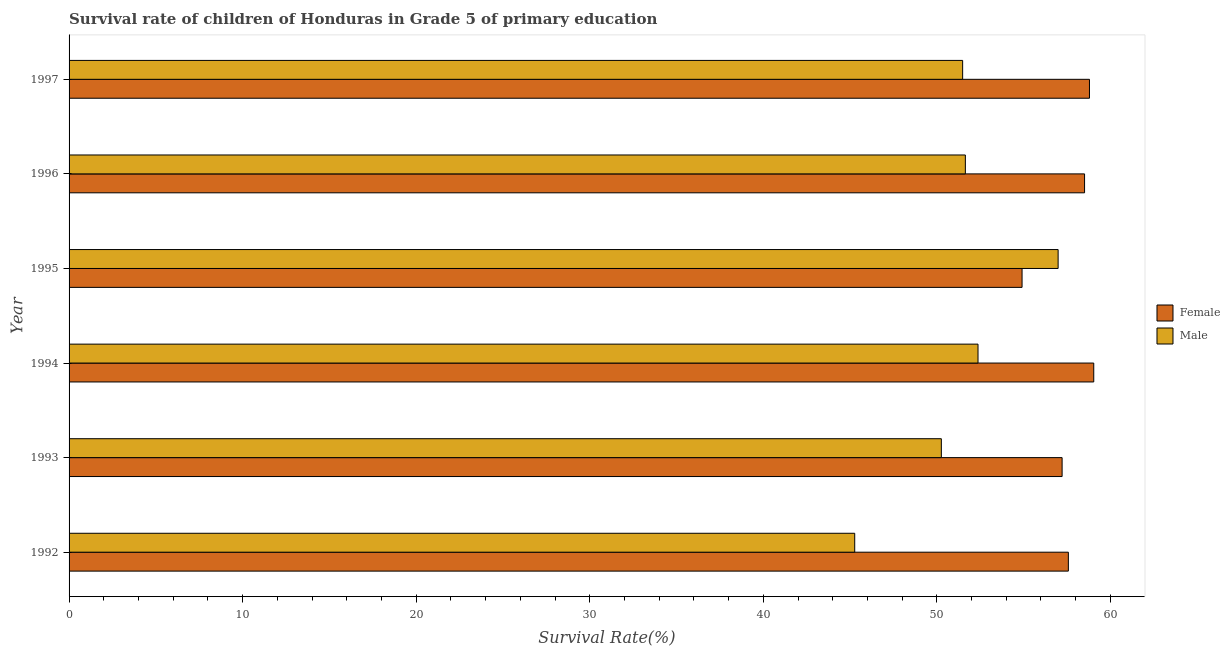How many different coloured bars are there?
Provide a short and direct response. 2. How many groups of bars are there?
Provide a succinct answer. 6. Are the number of bars on each tick of the Y-axis equal?
Offer a terse response. Yes. What is the label of the 4th group of bars from the top?
Keep it short and to the point. 1994. In how many cases, is the number of bars for a given year not equal to the number of legend labels?
Ensure brevity in your answer.  0. What is the survival rate of female students in primary education in 1996?
Ensure brevity in your answer.  58.51. Across all years, what is the maximum survival rate of male students in primary education?
Provide a short and direct response. 56.99. Across all years, what is the minimum survival rate of female students in primary education?
Your answer should be compact. 54.91. In which year was the survival rate of male students in primary education maximum?
Ensure brevity in your answer.  1995. In which year was the survival rate of male students in primary education minimum?
Provide a succinct answer. 1992. What is the total survival rate of female students in primary education in the graph?
Your answer should be compact. 346.05. What is the difference between the survival rate of male students in primary education in 1994 and that in 1995?
Provide a succinct answer. -4.62. What is the difference between the survival rate of female students in primary education in 1995 and the survival rate of male students in primary education in 1993?
Keep it short and to the point. 4.65. What is the average survival rate of male students in primary education per year?
Your answer should be very brief. 51.34. In the year 1993, what is the difference between the survival rate of female students in primary education and survival rate of male students in primary education?
Offer a terse response. 6.96. Is the survival rate of female students in primary education in 1993 less than that in 1995?
Keep it short and to the point. No. Is the difference between the survival rate of male students in primary education in 1993 and 1994 greater than the difference between the survival rate of female students in primary education in 1993 and 1994?
Offer a very short reply. No. What is the difference between the highest and the second highest survival rate of female students in primary education?
Give a very brief answer. 0.25. What is the difference between the highest and the lowest survival rate of male students in primary education?
Your answer should be compact. 11.72. In how many years, is the survival rate of male students in primary education greater than the average survival rate of male students in primary education taken over all years?
Your answer should be very brief. 4. Are all the bars in the graph horizontal?
Provide a short and direct response. Yes. How many years are there in the graph?
Keep it short and to the point. 6. Where does the legend appear in the graph?
Ensure brevity in your answer.  Center right. What is the title of the graph?
Your answer should be compact. Survival rate of children of Honduras in Grade 5 of primary education. What is the label or title of the X-axis?
Provide a succinct answer. Survival Rate(%). What is the Survival Rate(%) of Female in 1992?
Give a very brief answer. 57.58. What is the Survival Rate(%) in Male in 1992?
Provide a short and direct response. 45.27. What is the Survival Rate(%) in Female in 1993?
Keep it short and to the point. 57.22. What is the Survival Rate(%) in Male in 1993?
Give a very brief answer. 50.26. What is the Survival Rate(%) of Female in 1994?
Offer a terse response. 59.04. What is the Survival Rate(%) in Male in 1994?
Give a very brief answer. 52.37. What is the Survival Rate(%) of Female in 1995?
Give a very brief answer. 54.91. What is the Survival Rate(%) in Male in 1995?
Provide a short and direct response. 56.99. What is the Survival Rate(%) of Female in 1996?
Your response must be concise. 58.51. What is the Survival Rate(%) of Male in 1996?
Provide a succinct answer. 51.64. What is the Survival Rate(%) in Female in 1997?
Offer a very short reply. 58.79. What is the Survival Rate(%) in Male in 1997?
Your answer should be compact. 51.49. Across all years, what is the maximum Survival Rate(%) of Female?
Your answer should be very brief. 59.04. Across all years, what is the maximum Survival Rate(%) of Male?
Offer a terse response. 56.99. Across all years, what is the minimum Survival Rate(%) in Female?
Ensure brevity in your answer.  54.91. Across all years, what is the minimum Survival Rate(%) of Male?
Your response must be concise. 45.27. What is the total Survival Rate(%) of Female in the graph?
Offer a terse response. 346.05. What is the total Survival Rate(%) in Male in the graph?
Provide a succinct answer. 308.02. What is the difference between the Survival Rate(%) of Female in 1992 and that in 1993?
Offer a very short reply. 0.36. What is the difference between the Survival Rate(%) in Male in 1992 and that in 1993?
Offer a very short reply. -4.99. What is the difference between the Survival Rate(%) of Female in 1992 and that in 1994?
Provide a succinct answer. -1.46. What is the difference between the Survival Rate(%) in Male in 1992 and that in 1994?
Your answer should be very brief. -7.1. What is the difference between the Survival Rate(%) in Female in 1992 and that in 1995?
Your answer should be compact. 2.67. What is the difference between the Survival Rate(%) of Male in 1992 and that in 1995?
Give a very brief answer. -11.72. What is the difference between the Survival Rate(%) in Female in 1992 and that in 1996?
Your answer should be compact. -0.93. What is the difference between the Survival Rate(%) of Male in 1992 and that in 1996?
Offer a very short reply. -6.37. What is the difference between the Survival Rate(%) in Female in 1992 and that in 1997?
Ensure brevity in your answer.  -1.22. What is the difference between the Survival Rate(%) in Male in 1992 and that in 1997?
Offer a very short reply. -6.22. What is the difference between the Survival Rate(%) of Female in 1993 and that in 1994?
Keep it short and to the point. -1.82. What is the difference between the Survival Rate(%) of Male in 1993 and that in 1994?
Ensure brevity in your answer.  -2.11. What is the difference between the Survival Rate(%) of Female in 1993 and that in 1995?
Provide a succinct answer. 2.31. What is the difference between the Survival Rate(%) in Male in 1993 and that in 1995?
Offer a terse response. -6.73. What is the difference between the Survival Rate(%) of Female in 1993 and that in 1996?
Ensure brevity in your answer.  -1.29. What is the difference between the Survival Rate(%) in Male in 1993 and that in 1996?
Your answer should be compact. -1.38. What is the difference between the Survival Rate(%) in Female in 1993 and that in 1997?
Provide a short and direct response. -1.58. What is the difference between the Survival Rate(%) of Male in 1993 and that in 1997?
Provide a succinct answer. -1.23. What is the difference between the Survival Rate(%) of Female in 1994 and that in 1995?
Provide a short and direct response. 4.13. What is the difference between the Survival Rate(%) of Male in 1994 and that in 1995?
Make the answer very short. -4.62. What is the difference between the Survival Rate(%) of Female in 1994 and that in 1996?
Provide a short and direct response. 0.53. What is the difference between the Survival Rate(%) of Male in 1994 and that in 1996?
Ensure brevity in your answer.  0.73. What is the difference between the Survival Rate(%) in Female in 1994 and that in 1997?
Your answer should be compact. 0.25. What is the difference between the Survival Rate(%) of Male in 1994 and that in 1997?
Ensure brevity in your answer.  0.89. What is the difference between the Survival Rate(%) in Female in 1995 and that in 1996?
Provide a short and direct response. -3.6. What is the difference between the Survival Rate(%) in Male in 1995 and that in 1996?
Provide a short and direct response. 5.34. What is the difference between the Survival Rate(%) of Female in 1995 and that in 1997?
Give a very brief answer. -3.88. What is the difference between the Survival Rate(%) in Male in 1995 and that in 1997?
Provide a short and direct response. 5.5. What is the difference between the Survival Rate(%) of Female in 1996 and that in 1997?
Make the answer very short. -0.28. What is the difference between the Survival Rate(%) of Male in 1996 and that in 1997?
Offer a terse response. 0.16. What is the difference between the Survival Rate(%) of Female in 1992 and the Survival Rate(%) of Male in 1993?
Keep it short and to the point. 7.32. What is the difference between the Survival Rate(%) in Female in 1992 and the Survival Rate(%) in Male in 1994?
Ensure brevity in your answer.  5.21. What is the difference between the Survival Rate(%) of Female in 1992 and the Survival Rate(%) of Male in 1995?
Offer a very short reply. 0.59. What is the difference between the Survival Rate(%) in Female in 1992 and the Survival Rate(%) in Male in 1996?
Provide a succinct answer. 5.93. What is the difference between the Survival Rate(%) in Female in 1992 and the Survival Rate(%) in Male in 1997?
Your answer should be very brief. 6.09. What is the difference between the Survival Rate(%) of Female in 1993 and the Survival Rate(%) of Male in 1994?
Keep it short and to the point. 4.84. What is the difference between the Survival Rate(%) in Female in 1993 and the Survival Rate(%) in Male in 1995?
Provide a succinct answer. 0.23. What is the difference between the Survival Rate(%) in Female in 1993 and the Survival Rate(%) in Male in 1996?
Your response must be concise. 5.57. What is the difference between the Survival Rate(%) in Female in 1993 and the Survival Rate(%) in Male in 1997?
Offer a very short reply. 5.73. What is the difference between the Survival Rate(%) of Female in 1994 and the Survival Rate(%) of Male in 1995?
Ensure brevity in your answer.  2.05. What is the difference between the Survival Rate(%) in Female in 1994 and the Survival Rate(%) in Male in 1996?
Your answer should be compact. 7.4. What is the difference between the Survival Rate(%) of Female in 1994 and the Survival Rate(%) of Male in 1997?
Ensure brevity in your answer.  7.55. What is the difference between the Survival Rate(%) of Female in 1995 and the Survival Rate(%) of Male in 1996?
Your response must be concise. 3.27. What is the difference between the Survival Rate(%) of Female in 1995 and the Survival Rate(%) of Male in 1997?
Your response must be concise. 3.42. What is the difference between the Survival Rate(%) of Female in 1996 and the Survival Rate(%) of Male in 1997?
Your response must be concise. 7.02. What is the average Survival Rate(%) in Female per year?
Your answer should be very brief. 57.68. What is the average Survival Rate(%) in Male per year?
Make the answer very short. 51.34. In the year 1992, what is the difference between the Survival Rate(%) in Female and Survival Rate(%) in Male?
Give a very brief answer. 12.31. In the year 1993, what is the difference between the Survival Rate(%) of Female and Survival Rate(%) of Male?
Provide a short and direct response. 6.96. In the year 1994, what is the difference between the Survival Rate(%) of Female and Survival Rate(%) of Male?
Make the answer very short. 6.67. In the year 1995, what is the difference between the Survival Rate(%) in Female and Survival Rate(%) in Male?
Your answer should be compact. -2.08. In the year 1996, what is the difference between the Survival Rate(%) of Female and Survival Rate(%) of Male?
Keep it short and to the point. 6.87. In the year 1997, what is the difference between the Survival Rate(%) in Female and Survival Rate(%) in Male?
Make the answer very short. 7.31. What is the ratio of the Survival Rate(%) of Female in 1992 to that in 1993?
Your answer should be compact. 1.01. What is the ratio of the Survival Rate(%) of Male in 1992 to that in 1993?
Your answer should be very brief. 0.9. What is the ratio of the Survival Rate(%) of Female in 1992 to that in 1994?
Your response must be concise. 0.98. What is the ratio of the Survival Rate(%) of Male in 1992 to that in 1994?
Your response must be concise. 0.86. What is the ratio of the Survival Rate(%) in Female in 1992 to that in 1995?
Keep it short and to the point. 1.05. What is the ratio of the Survival Rate(%) in Male in 1992 to that in 1995?
Make the answer very short. 0.79. What is the ratio of the Survival Rate(%) in Male in 1992 to that in 1996?
Offer a terse response. 0.88. What is the ratio of the Survival Rate(%) of Female in 1992 to that in 1997?
Offer a terse response. 0.98. What is the ratio of the Survival Rate(%) of Male in 1992 to that in 1997?
Your response must be concise. 0.88. What is the ratio of the Survival Rate(%) of Female in 1993 to that in 1994?
Your answer should be compact. 0.97. What is the ratio of the Survival Rate(%) of Male in 1993 to that in 1994?
Offer a terse response. 0.96. What is the ratio of the Survival Rate(%) of Female in 1993 to that in 1995?
Offer a terse response. 1.04. What is the ratio of the Survival Rate(%) in Male in 1993 to that in 1995?
Offer a terse response. 0.88. What is the ratio of the Survival Rate(%) in Female in 1993 to that in 1996?
Your answer should be very brief. 0.98. What is the ratio of the Survival Rate(%) of Male in 1993 to that in 1996?
Provide a short and direct response. 0.97. What is the ratio of the Survival Rate(%) of Female in 1993 to that in 1997?
Make the answer very short. 0.97. What is the ratio of the Survival Rate(%) in Male in 1993 to that in 1997?
Offer a terse response. 0.98. What is the ratio of the Survival Rate(%) in Female in 1994 to that in 1995?
Ensure brevity in your answer.  1.08. What is the ratio of the Survival Rate(%) in Male in 1994 to that in 1995?
Your response must be concise. 0.92. What is the ratio of the Survival Rate(%) in Female in 1994 to that in 1996?
Keep it short and to the point. 1.01. What is the ratio of the Survival Rate(%) of Male in 1994 to that in 1996?
Provide a succinct answer. 1.01. What is the ratio of the Survival Rate(%) of Female in 1994 to that in 1997?
Your response must be concise. 1. What is the ratio of the Survival Rate(%) of Male in 1994 to that in 1997?
Give a very brief answer. 1.02. What is the ratio of the Survival Rate(%) in Female in 1995 to that in 1996?
Offer a terse response. 0.94. What is the ratio of the Survival Rate(%) in Male in 1995 to that in 1996?
Offer a very short reply. 1.1. What is the ratio of the Survival Rate(%) of Female in 1995 to that in 1997?
Your response must be concise. 0.93. What is the ratio of the Survival Rate(%) in Male in 1995 to that in 1997?
Provide a short and direct response. 1.11. What is the ratio of the Survival Rate(%) of Male in 1996 to that in 1997?
Your answer should be compact. 1. What is the difference between the highest and the second highest Survival Rate(%) of Female?
Your answer should be compact. 0.25. What is the difference between the highest and the second highest Survival Rate(%) in Male?
Ensure brevity in your answer.  4.62. What is the difference between the highest and the lowest Survival Rate(%) in Female?
Keep it short and to the point. 4.13. What is the difference between the highest and the lowest Survival Rate(%) in Male?
Provide a succinct answer. 11.72. 